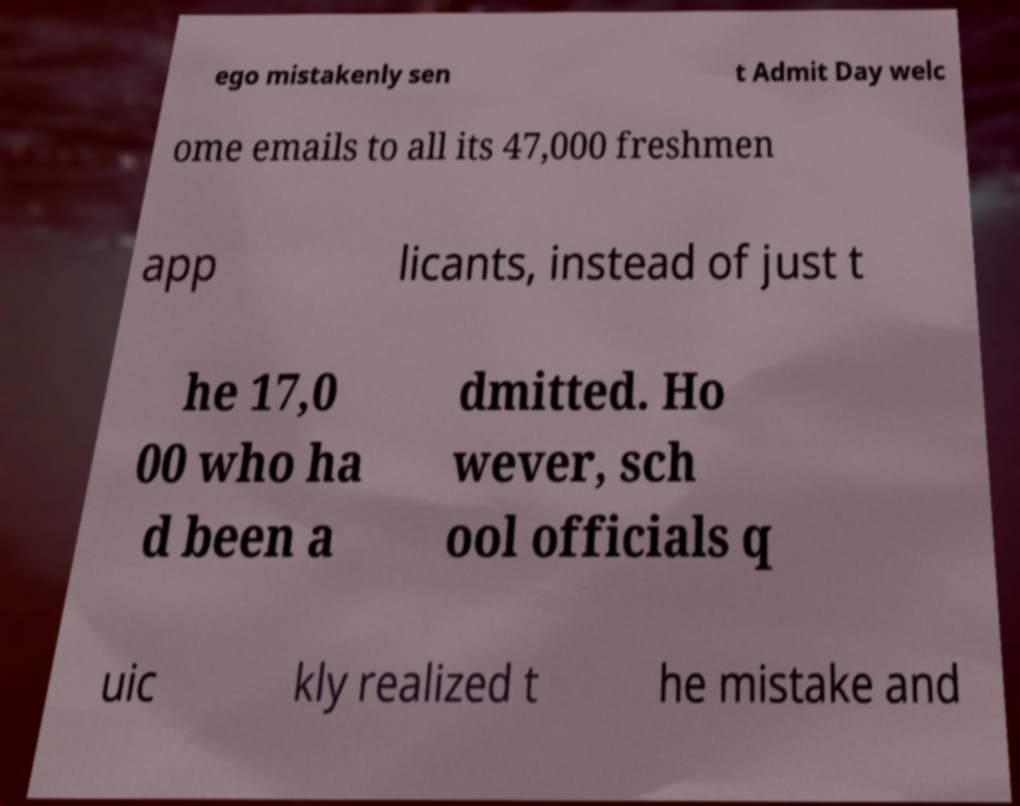Please identify and transcribe the text found in this image. ego mistakenly sen t Admit Day welc ome emails to all its 47,000 freshmen app licants, instead of just t he 17,0 00 who ha d been a dmitted. Ho wever, sch ool officials q uic kly realized t he mistake and 